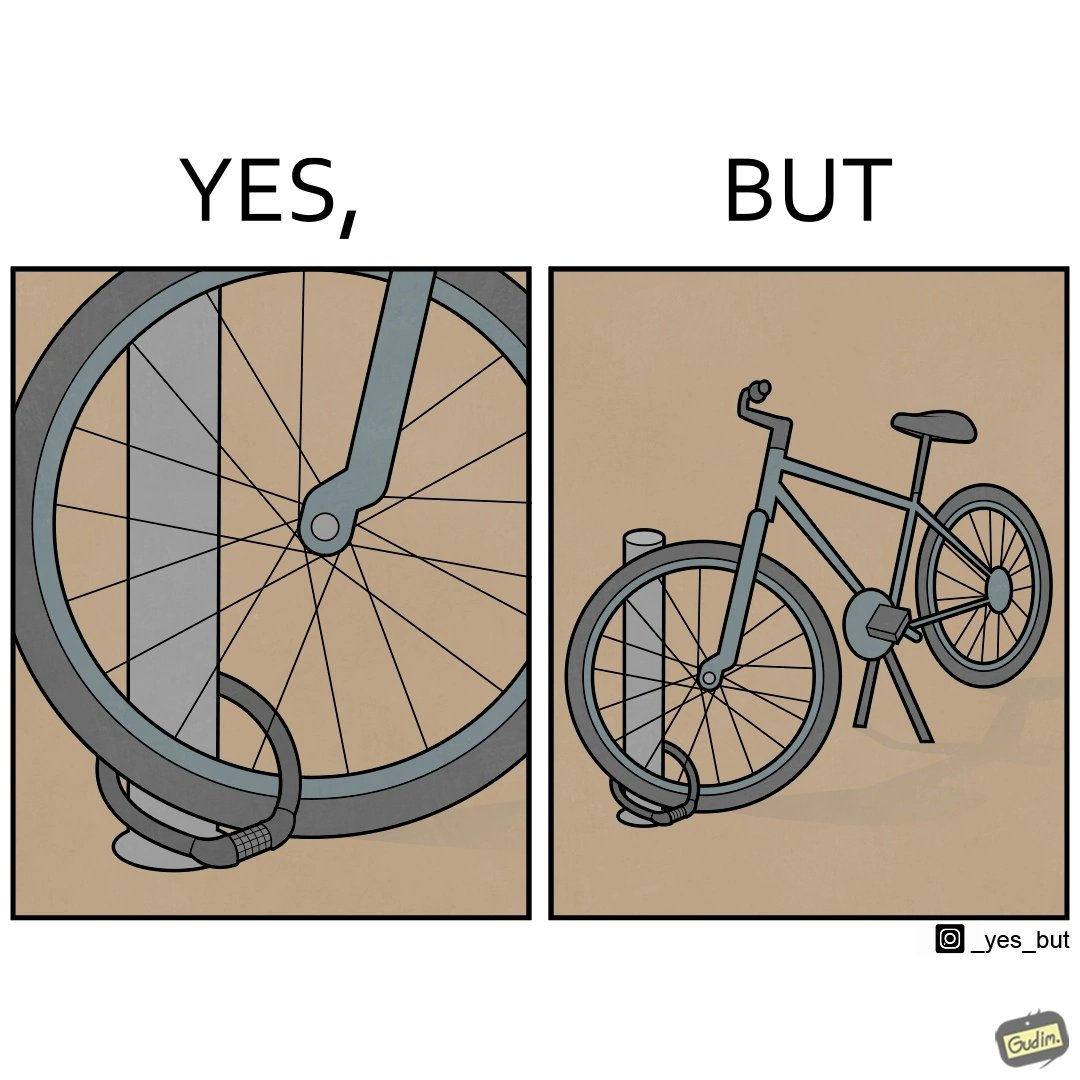Explain the humor or irony in this image. the irony is that people lock their bikes on poles where anyone can just lift the bike out of the pole 